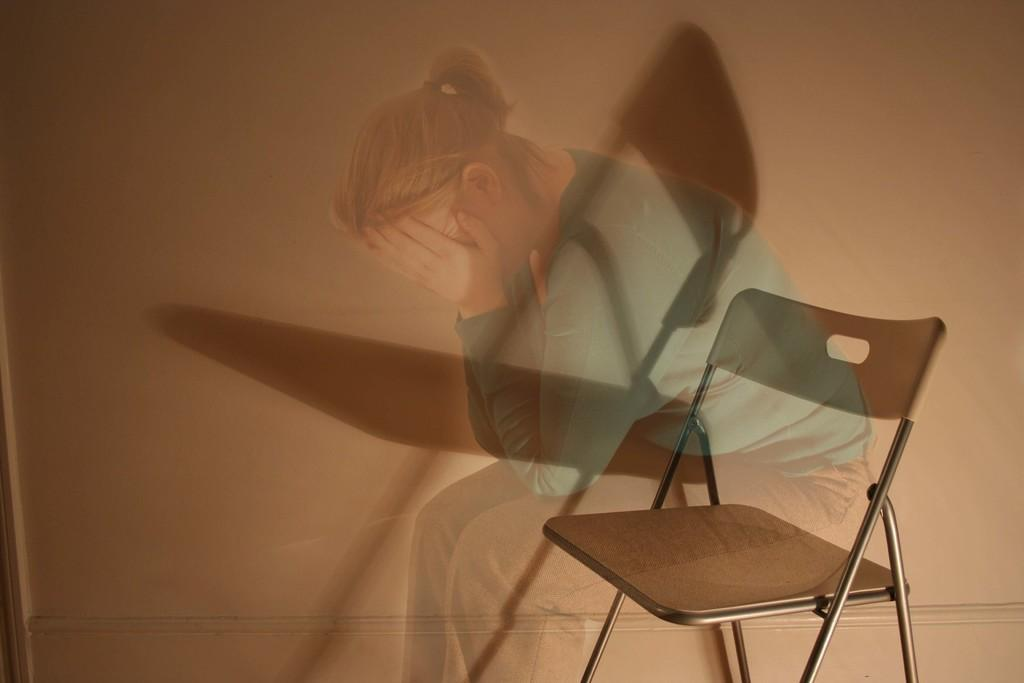What type of image is being described? The image appears to be an edited picture. What object is located in the foreground of the image? There is a chair in the foreground of the image. What can be seen in the background of the image? There is a wall in the background of the image. What is depicted on the wall in the image? There is a picture of a woman on the wall. What type of throne is the woman sitting on in the image? There is no throne or woman sitting in the image; it features a picture of a woman on the wall. What type of board is being used to edit the image? The facts provided do not mention any specific editing tools or software, so it is not possible to determine the type of board used to edit the image. 